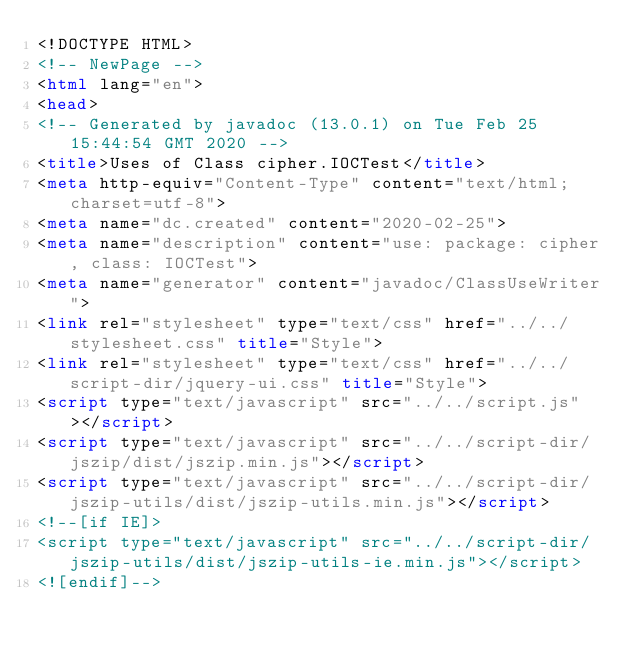<code> <loc_0><loc_0><loc_500><loc_500><_HTML_><!DOCTYPE HTML>
<!-- NewPage -->
<html lang="en">
<head>
<!-- Generated by javadoc (13.0.1) on Tue Feb 25 15:44:54 GMT 2020 -->
<title>Uses of Class cipher.IOCTest</title>
<meta http-equiv="Content-Type" content="text/html; charset=utf-8">
<meta name="dc.created" content="2020-02-25">
<meta name="description" content="use: package: cipher, class: IOCTest">
<meta name="generator" content="javadoc/ClassUseWriter">
<link rel="stylesheet" type="text/css" href="../../stylesheet.css" title="Style">
<link rel="stylesheet" type="text/css" href="../../script-dir/jquery-ui.css" title="Style">
<script type="text/javascript" src="../../script.js"></script>
<script type="text/javascript" src="../../script-dir/jszip/dist/jszip.min.js"></script>
<script type="text/javascript" src="../../script-dir/jszip-utils/dist/jszip-utils.min.js"></script>
<!--[if IE]>
<script type="text/javascript" src="../../script-dir/jszip-utils/dist/jszip-utils-ie.min.js"></script>
<![endif]--></code> 